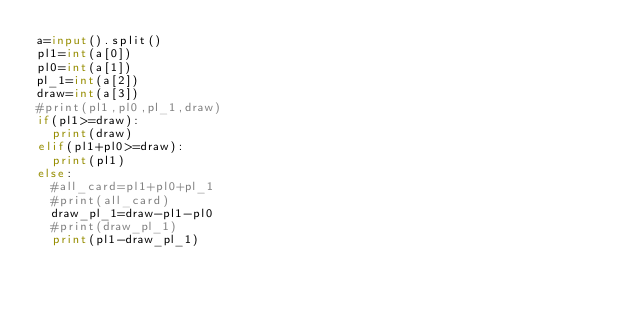Convert code to text. <code><loc_0><loc_0><loc_500><loc_500><_Python_>a=input().split()
pl1=int(a[0])
pl0=int(a[1])
pl_1=int(a[2])
draw=int(a[3])
#print(pl1,pl0,pl_1,draw)
if(pl1>=draw):
  print(draw)
elif(pl1+pl0>=draw):
  print(pl1)
else:
  #all_card=pl1+pl0+pl_1
  #print(all_card)
  draw_pl_1=draw-pl1-pl0
  #print(draw_pl_1)
  print(pl1-draw_pl_1)</code> 